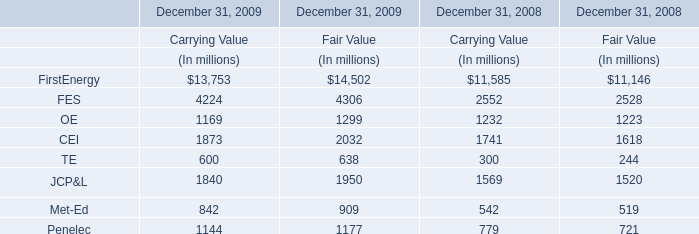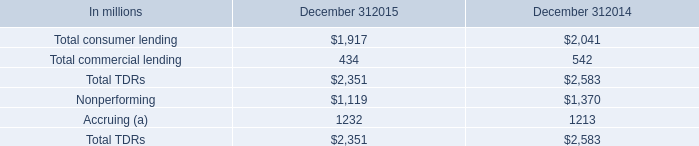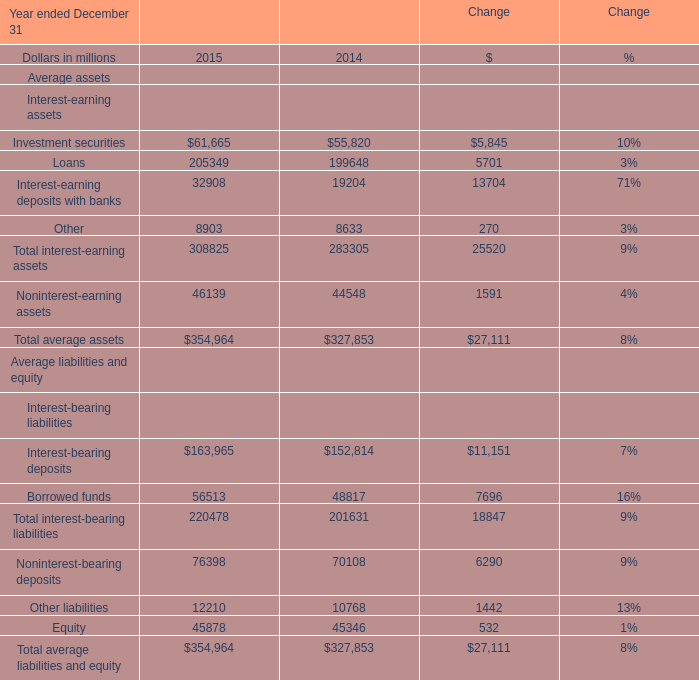The value of Total average assets for which Year ended December 31 ranks first? 
Answer: 2015. 